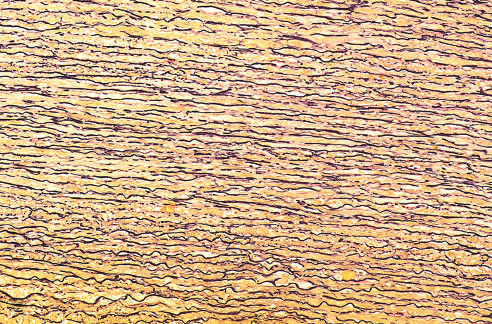what is stained black in the figure?
Answer the question using a single word or phrase. Elastin 